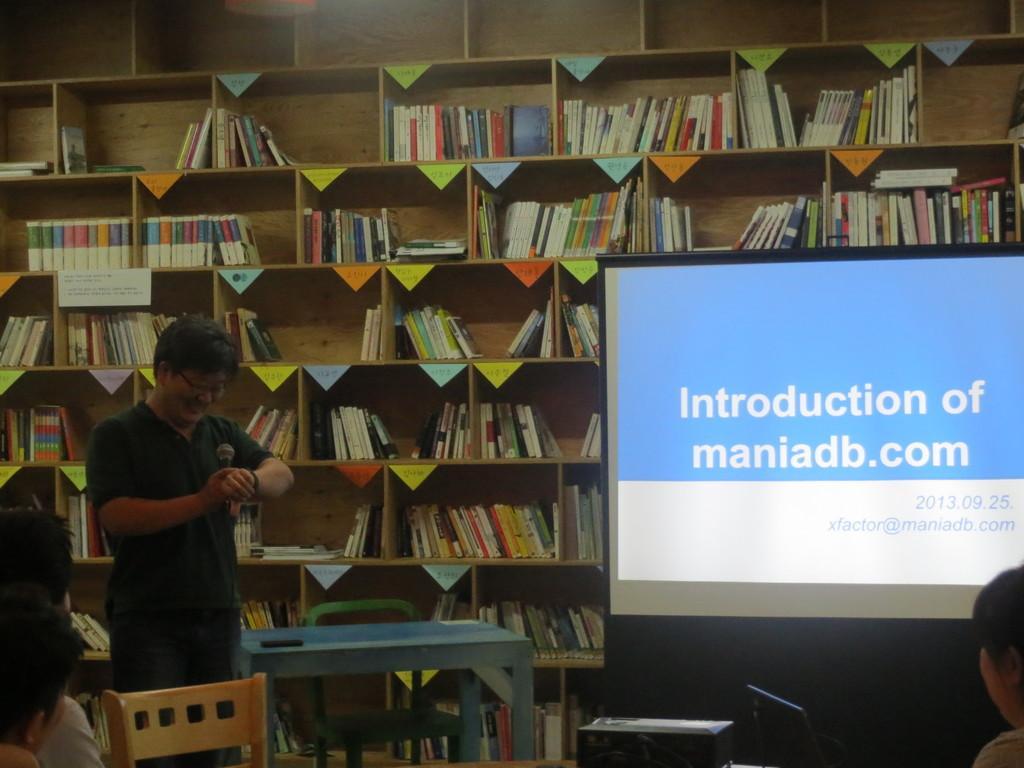Can you describe this image briefly? Here in this image we can see a man holding a microphone and looking at his own hand, on the right side of the image we can see a digital screen, in the middle there is a table and chair, in the background can see a book rack and their number of books here, on the left side we can see two people. 